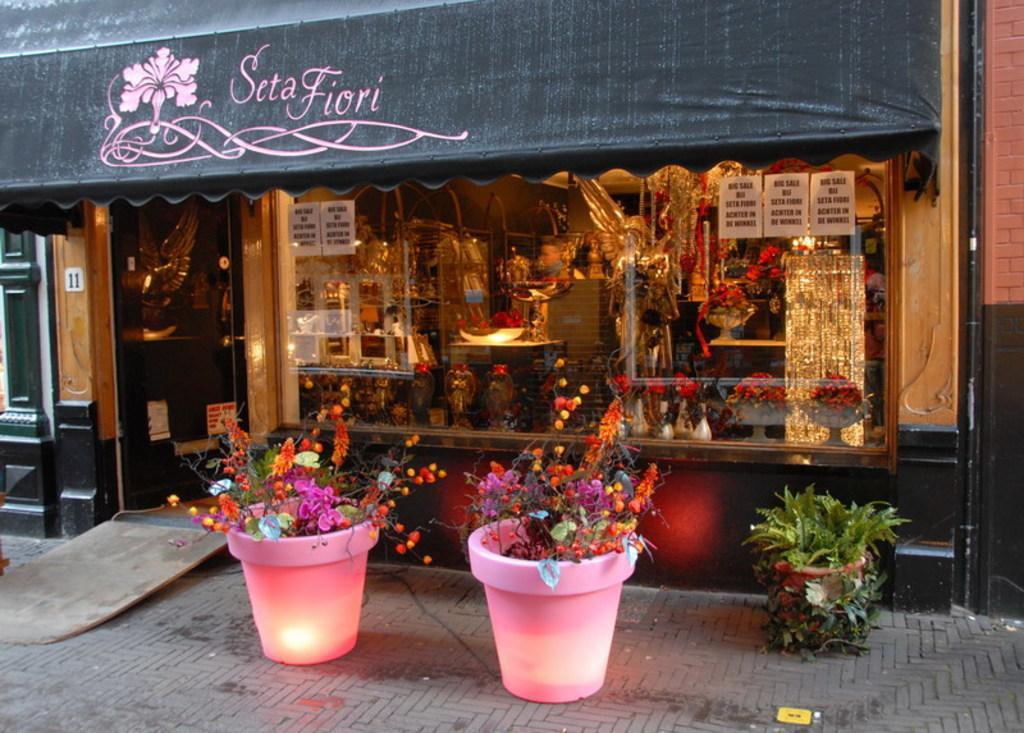In one or two sentences, can you explain what this image depicts? In this picture we can see there are house plants and behind the plants there is a shop and in the shop there are some items. 